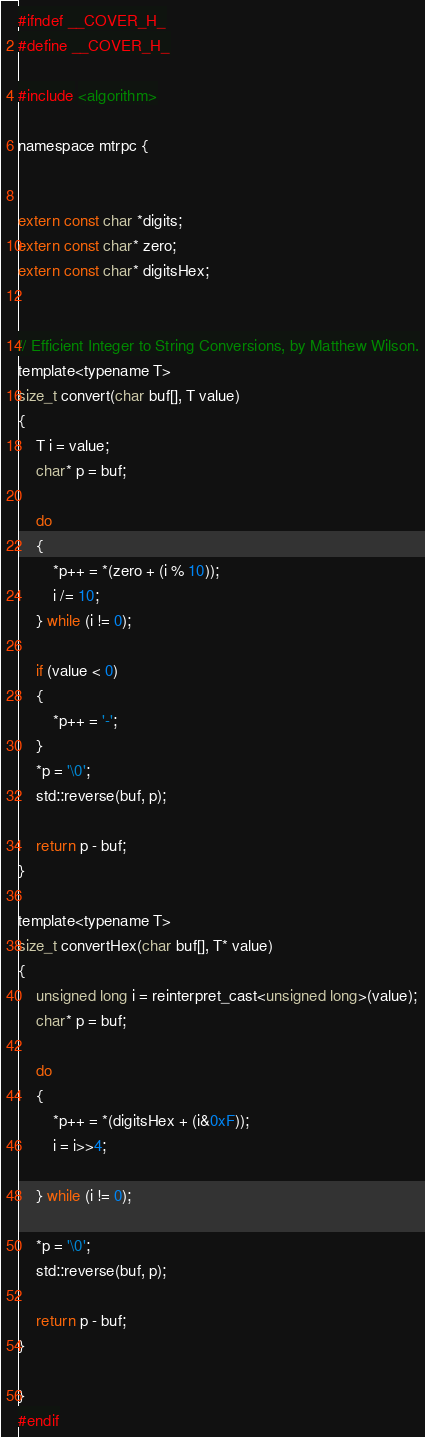<code> <loc_0><loc_0><loc_500><loc_500><_C_>#ifndef __COVER_H_
#define __COVER_H_

#include <algorithm>

namespace mtrpc {


extern const char *digits;
extern const char* zero;
extern const char* digitsHex;


// Efficient Integer to String Conversions, by Matthew Wilson.
template<typename T>
size_t convert(char buf[], T value)
{
    T i = value;
    char* p = buf;

    do
    {
        *p++ = *(zero + (i % 10));
        i /= 10;
    } while (i != 0);

    if (value < 0)
    {
        *p++ = '-';
    }
    *p = '\0';
    std::reverse(buf, p);

    return p - buf;
}

template<typename T>
size_t convertHex(char buf[], T* value)
{
    unsigned long i = reinterpret_cast<unsigned long>(value);
    char* p = buf;

    do
    {
        *p++ = *(digitsHex + (i&0xF));
        i = i>>4;

    } while (i != 0);

    *p = '\0';
    std::reverse(buf, p);

    return p - buf;
}

}
#endif
</code> 